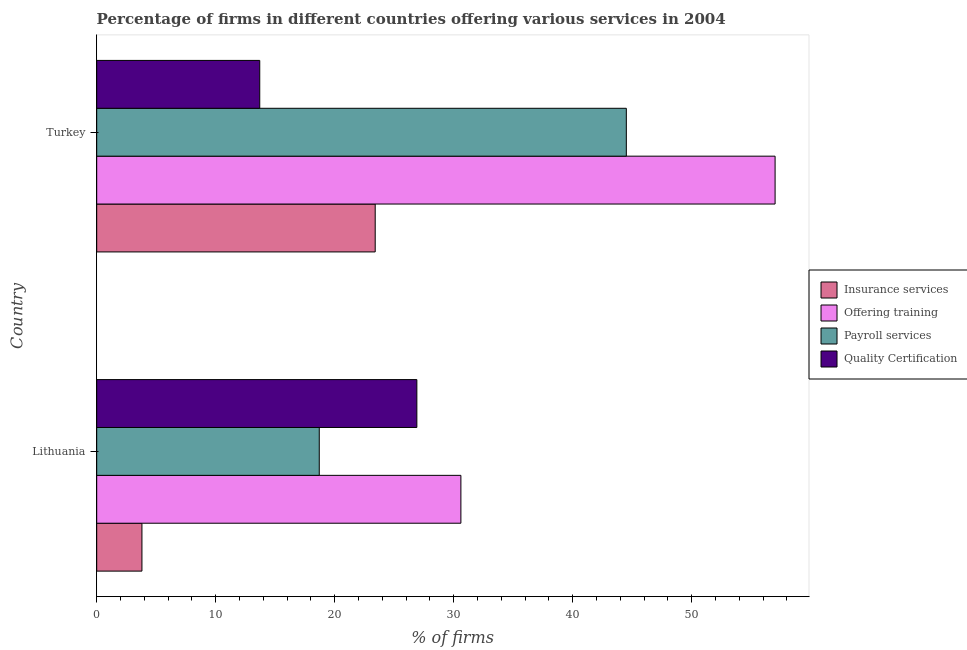How many different coloured bars are there?
Ensure brevity in your answer.  4. Are the number of bars on each tick of the Y-axis equal?
Your answer should be compact. Yes. How many bars are there on the 1st tick from the top?
Make the answer very short. 4. How many bars are there on the 2nd tick from the bottom?
Offer a terse response. 4. In how many cases, is the number of bars for a given country not equal to the number of legend labels?
Offer a terse response. 0. What is the percentage of firms offering payroll services in Turkey?
Provide a short and direct response. 44.5. Across all countries, what is the maximum percentage of firms offering quality certification?
Your response must be concise. 26.9. In which country was the percentage of firms offering training maximum?
Your response must be concise. Turkey. In which country was the percentage of firms offering insurance services minimum?
Offer a terse response. Lithuania. What is the total percentage of firms offering payroll services in the graph?
Ensure brevity in your answer.  63.2. What is the difference between the percentage of firms offering quality certification in Lithuania and that in Turkey?
Keep it short and to the point. 13.2. What is the difference between the percentage of firms offering payroll services in Lithuania and the percentage of firms offering training in Turkey?
Keep it short and to the point. -38.3. What is the average percentage of firms offering quality certification per country?
Your answer should be very brief. 20.3. What is the difference between the percentage of firms offering insurance services and percentage of firms offering training in Lithuania?
Provide a succinct answer. -26.8. What is the ratio of the percentage of firms offering insurance services in Lithuania to that in Turkey?
Your answer should be very brief. 0.16. Is the percentage of firms offering insurance services in Lithuania less than that in Turkey?
Ensure brevity in your answer.  Yes. Is the difference between the percentage of firms offering quality certification in Lithuania and Turkey greater than the difference between the percentage of firms offering training in Lithuania and Turkey?
Offer a terse response. Yes. In how many countries, is the percentage of firms offering training greater than the average percentage of firms offering training taken over all countries?
Give a very brief answer. 1. Is it the case that in every country, the sum of the percentage of firms offering quality certification and percentage of firms offering payroll services is greater than the sum of percentage of firms offering training and percentage of firms offering insurance services?
Offer a very short reply. No. What does the 3rd bar from the top in Lithuania represents?
Offer a terse response. Offering training. What does the 4th bar from the bottom in Lithuania represents?
Provide a short and direct response. Quality Certification. Is it the case that in every country, the sum of the percentage of firms offering insurance services and percentage of firms offering training is greater than the percentage of firms offering payroll services?
Your answer should be very brief. Yes. How many bars are there?
Give a very brief answer. 8. Are the values on the major ticks of X-axis written in scientific E-notation?
Give a very brief answer. No. Does the graph contain grids?
Make the answer very short. No. Where does the legend appear in the graph?
Your answer should be compact. Center right. How many legend labels are there?
Provide a short and direct response. 4. How are the legend labels stacked?
Your response must be concise. Vertical. What is the title of the graph?
Make the answer very short. Percentage of firms in different countries offering various services in 2004. Does "Insurance services" appear as one of the legend labels in the graph?
Keep it short and to the point. Yes. What is the label or title of the X-axis?
Ensure brevity in your answer.  % of firms. What is the % of firms of Offering training in Lithuania?
Keep it short and to the point. 30.6. What is the % of firms of Payroll services in Lithuania?
Make the answer very short. 18.7. What is the % of firms in Quality Certification in Lithuania?
Keep it short and to the point. 26.9. What is the % of firms of Insurance services in Turkey?
Offer a terse response. 23.4. What is the % of firms in Payroll services in Turkey?
Keep it short and to the point. 44.5. What is the % of firms of Quality Certification in Turkey?
Your answer should be very brief. 13.7. Across all countries, what is the maximum % of firms of Insurance services?
Your answer should be very brief. 23.4. Across all countries, what is the maximum % of firms of Offering training?
Offer a terse response. 57. Across all countries, what is the maximum % of firms of Payroll services?
Provide a short and direct response. 44.5. Across all countries, what is the maximum % of firms in Quality Certification?
Give a very brief answer. 26.9. Across all countries, what is the minimum % of firms of Insurance services?
Give a very brief answer. 3.8. Across all countries, what is the minimum % of firms in Offering training?
Make the answer very short. 30.6. Across all countries, what is the minimum % of firms of Payroll services?
Give a very brief answer. 18.7. What is the total % of firms in Insurance services in the graph?
Your answer should be compact. 27.2. What is the total % of firms in Offering training in the graph?
Your answer should be compact. 87.6. What is the total % of firms of Payroll services in the graph?
Keep it short and to the point. 63.2. What is the total % of firms of Quality Certification in the graph?
Keep it short and to the point. 40.6. What is the difference between the % of firms of Insurance services in Lithuania and that in Turkey?
Your response must be concise. -19.6. What is the difference between the % of firms in Offering training in Lithuania and that in Turkey?
Keep it short and to the point. -26.4. What is the difference between the % of firms of Payroll services in Lithuania and that in Turkey?
Ensure brevity in your answer.  -25.8. What is the difference between the % of firms of Insurance services in Lithuania and the % of firms of Offering training in Turkey?
Give a very brief answer. -53.2. What is the difference between the % of firms in Insurance services in Lithuania and the % of firms in Payroll services in Turkey?
Provide a short and direct response. -40.7. What is the difference between the % of firms in Insurance services in Lithuania and the % of firms in Quality Certification in Turkey?
Your answer should be very brief. -9.9. What is the difference between the % of firms in Payroll services in Lithuania and the % of firms in Quality Certification in Turkey?
Ensure brevity in your answer.  5. What is the average % of firms in Offering training per country?
Offer a very short reply. 43.8. What is the average % of firms of Payroll services per country?
Your answer should be compact. 31.6. What is the average % of firms in Quality Certification per country?
Your answer should be compact. 20.3. What is the difference between the % of firms in Insurance services and % of firms in Offering training in Lithuania?
Make the answer very short. -26.8. What is the difference between the % of firms in Insurance services and % of firms in Payroll services in Lithuania?
Make the answer very short. -14.9. What is the difference between the % of firms of Insurance services and % of firms of Quality Certification in Lithuania?
Give a very brief answer. -23.1. What is the difference between the % of firms of Offering training and % of firms of Payroll services in Lithuania?
Offer a very short reply. 11.9. What is the difference between the % of firms in Offering training and % of firms in Quality Certification in Lithuania?
Provide a succinct answer. 3.7. What is the difference between the % of firms of Payroll services and % of firms of Quality Certification in Lithuania?
Keep it short and to the point. -8.2. What is the difference between the % of firms in Insurance services and % of firms in Offering training in Turkey?
Provide a succinct answer. -33.6. What is the difference between the % of firms in Insurance services and % of firms in Payroll services in Turkey?
Give a very brief answer. -21.1. What is the difference between the % of firms of Offering training and % of firms of Payroll services in Turkey?
Offer a very short reply. 12.5. What is the difference between the % of firms of Offering training and % of firms of Quality Certification in Turkey?
Your answer should be compact. 43.3. What is the difference between the % of firms of Payroll services and % of firms of Quality Certification in Turkey?
Make the answer very short. 30.8. What is the ratio of the % of firms of Insurance services in Lithuania to that in Turkey?
Keep it short and to the point. 0.16. What is the ratio of the % of firms of Offering training in Lithuania to that in Turkey?
Keep it short and to the point. 0.54. What is the ratio of the % of firms in Payroll services in Lithuania to that in Turkey?
Keep it short and to the point. 0.42. What is the ratio of the % of firms in Quality Certification in Lithuania to that in Turkey?
Offer a very short reply. 1.96. What is the difference between the highest and the second highest % of firms in Insurance services?
Provide a succinct answer. 19.6. What is the difference between the highest and the second highest % of firms of Offering training?
Your response must be concise. 26.4. What is the difference between the highest and the second highest % of firms in Payroll services?
Your answer should be compact. 25.8. What is the difference between the highest and the second highest % of firms in Quality Certification?
Provide a short and direct response. 13.2. What is the difference between the highest and the lowest % of firms of Insurance services?
Provide a succinct answer. 19.6. What is the difference between the highest and the lowest % of firms in Offering training?
Offer a terse response. 26.4. What is the difference between the highest and the lowest % of firms in Payroll services?
Your answer should be very brief. 25.8. 